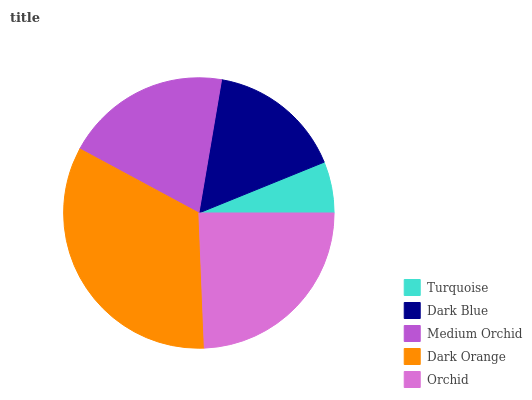Is Turquoise the minimum?
Answer yes or no. Yes. Is Dark Orange the maximum?
Answer yes or no. Yes. Is Dark Blue the minimum?
Answer yes or no. No. Is Dark Blue the maximum?
Answer yes or no. No. Is Dark Blue greater than Turquoise?
Answer yes or no. Yes. Is Turquoise less than Dark Blue?
Answer yes or no. Yes. Is Turquoise greater than Dark Blue?
Answer yes or no. No. Is Dark Blue less than Turquoise?
Answer yes or no. No. Is Medium Orchid the high median?
Answer yes or no. Yes. Is Medium Orchid the low median?
Answer yes or no. Yes. Is Dark Orange the high median?
Answer yes or no. No. Is Dark Orange the low median?
Answer yes or no. No. 